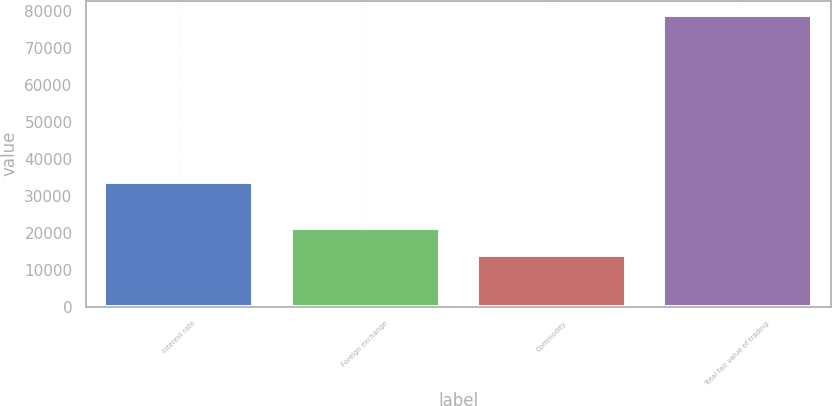Convert chart to OTSL. <chart><loc_0><loc_0><loc_500><loc_500><bar_chart><fcel>Interest rate<fcel>Foreign exchange<fcel>Commodity<fcel>Total fair value of trading<nl><fcel>33725<fcel>21253<fcel>13982<fcel>78975<nl></chart> 